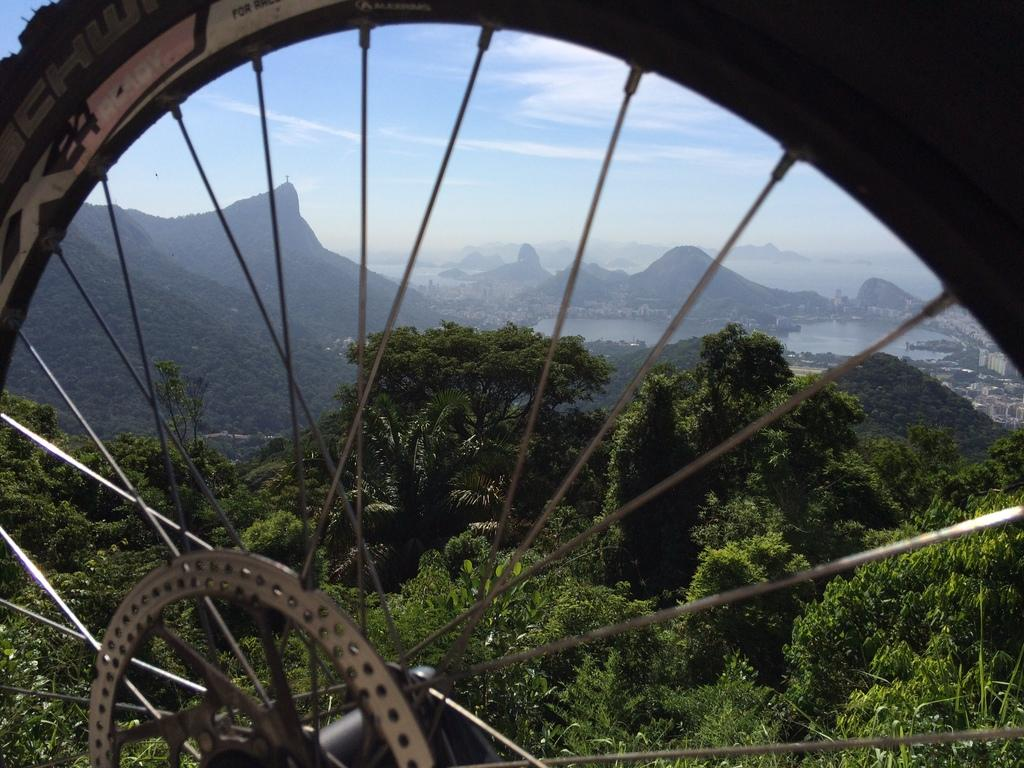What is the main object in the image? There is a wheel in the image. What type of natural environment is visible in the image? Trees, water, and a mountain are visible in the image. What is visible in the background of the image? The sky is visible in the background of the image. Where is the dad sleeping in the image? There is no dad or bed present in the image. What type of plant is growing near the wheel in the image? There is no plant visible in the image; only trees, water, and a mountain are present. 